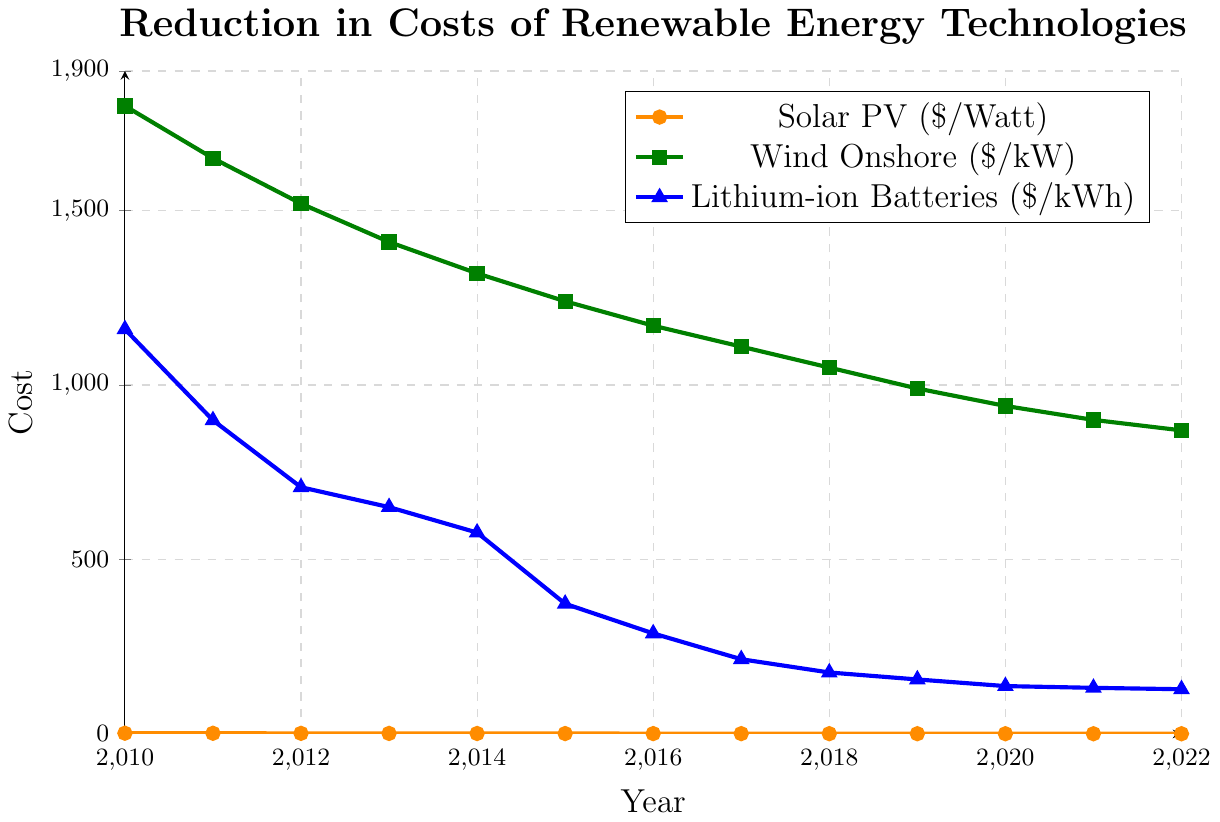What's the cost difference between Solar PV and Wind Onshore in 2010? In 2010, the cost of Solar PV is $1.96 per Watt and Wind Onshore is $1800 per kW. To find the difference, we subtract the smaller cost from the larger cost: $1800 - $1.96 = $1798.04.
Answer: $1798.04 Which technology had the steepest reduction in costs between 2010 and 2015? To determine the steepest reduction, we compare the cost differences over the period for each technology. For Solar PV: $1.96 - $0.98 = $0.98. For Wind Onshore: $1800 - $1240 = $560. For Lithium-ion Batteries: $1160 - $373 = $787. Since $787 is the largest difference, Lithium-ion Batteries had the steepest reduction.
Answer: Lithium-ion Batteries What was the cost of Lithium-ion Batteries in 2018, and how does it compare to its cost in 2022? The cost of Lithium-ion Batteries in 2018 is $176 per kWh, and in 2022 it is $128 per kWh. To compare, we see the difference: $176 - $128 = $48. Lithium-ion Batteries cost $48 less in 2022 than in 2018.
Answer: $48 less Among the given years, which year showed the smallest annual decrease in the cost of Wind Onshore? We look at the year-to-year costs for Wind Onshore and find the differences: 
2010 to 2011: $1800 - $1650 = $150
2011 to 2012: $1650 - $1520 = $130
2012 to 2013: $1520 - $1410 = $110
2013 to 2014: $1410 - $1320 = $90
2014 to 2015: $1320 - $1240 = $80
2015 to 2016: $1240 - $1170 = $70
2016 to 2017: $1170 - $1110 = $60
2017 to 2018: $1110 - $1050 = $60
2018 to 2019: $1050 - $990 = $60
2019 to 2020: $990 - $940 = $50
2020 to 2021: $940 - $900 = $40
2021 to 2022: $900 - $870 = $30
The smallest annual decrease was $30 between 2021 and 2022.
Answer: 2021 to 2022 In 2022, how does the cost of Solar PV compare with its cost in 2010 as a percentage decrease? To find the percentage decrease, we calculate: $(InitialCost - FinalCost) / InitialCost \times 100$. For Solar PV: $(1.96 - 0.38) / 1.96 \times 100 ≈ 80.61\%$.
Answer: Approximately 80.61% What’s the average cost of Wind Onshore over the years 2010-2022? Add the costs for each year and divide by the number of years (13):
($1800 + $1650 + $1520 + $1410 + $1320 + $1240 + $1170 + $1110 + $1050 + $990 + $940 + $900 + $870) / 13 = $1351.54.
Answer: $1351.54 Between 2013 and 2017, which technology experienced the greatest reduction in cost? Calculate the reduction for each technology between 2013 and 2017:
Solar PV: $1.34 - $0.72 = $0.62
Wind Onshore: $1410 - $1110 = $300
Lithium-ion Batteries: $650 - $214 = $436
Lithium-ion Batteries experienced the greatest reduction in cost.
Answer: Lithium-ion Batteries At what year did the cost of Solar PV fall below $1 per Watt? We track the costs of Solar PV over the years and find that it dropped to $0.98 in 2015, which is the first year it fell below $1 per Watt.
Answer: 2015 Which renewable technology had the lowest cost in 2022? From the graph, in 2022, the costs are Solar PV at $0.38 per Watt, Wind Onshore at $870 per kW, and Lithium-ion Batteries at $128 per kWh. Since $0.38 is the lowest value, Solar PV had the lowest cost in 2022.
Answer: Solar PV 